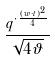<formula> <loc_0><loc_0><loc_500><loc_500>\frac { q ^ { \cdot \frac { ( w \cdot t ) ^ { 2 } } { 4 } } } { \sqrt { 4 \vartheta } }</formula> 